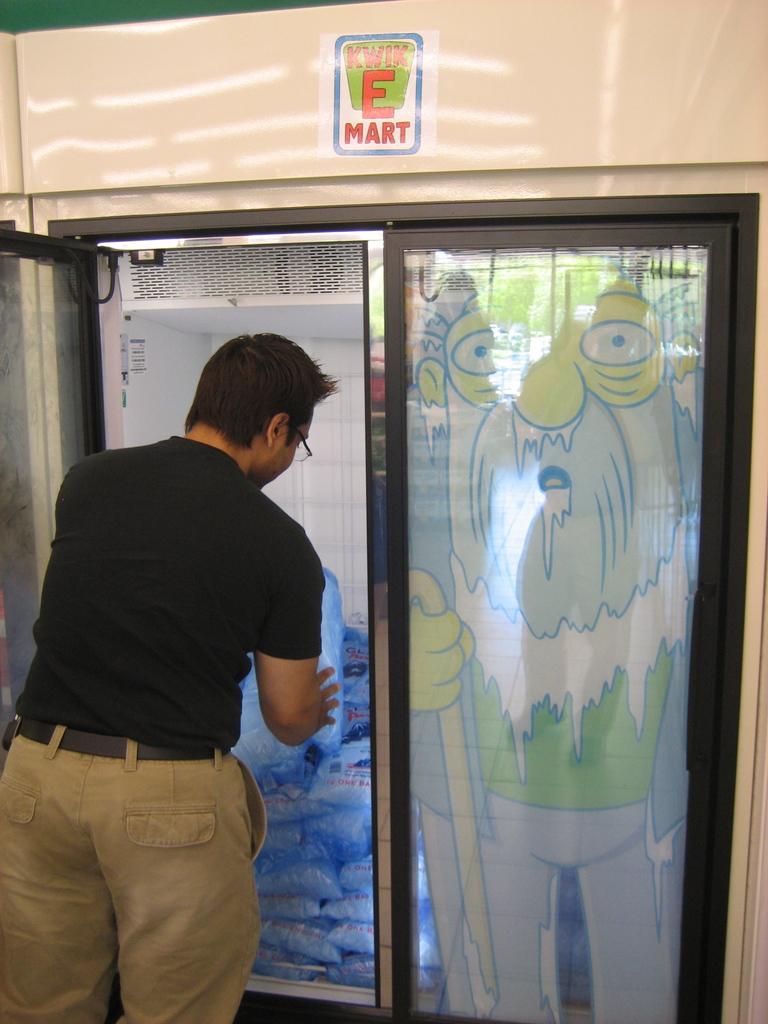What's the name of the store?
Provide a succinct answer. Kwik e mart. 